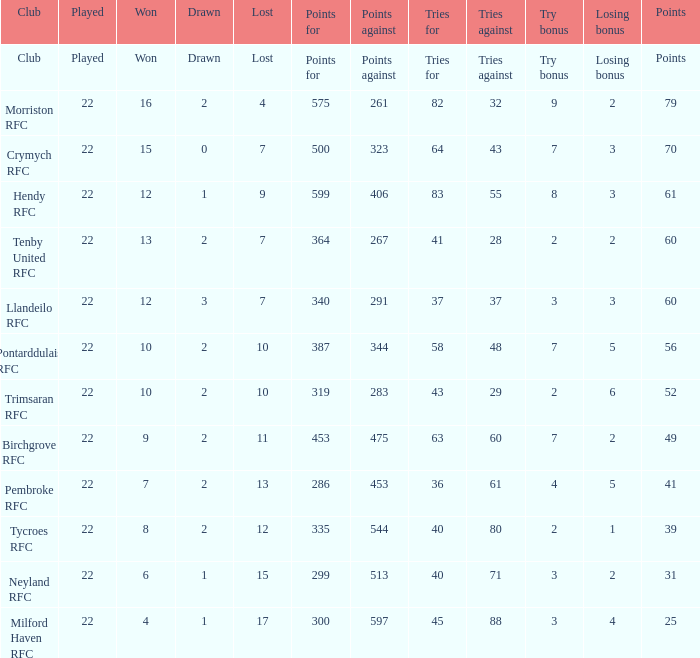How many points against with attempts for being 43? 1.0. 